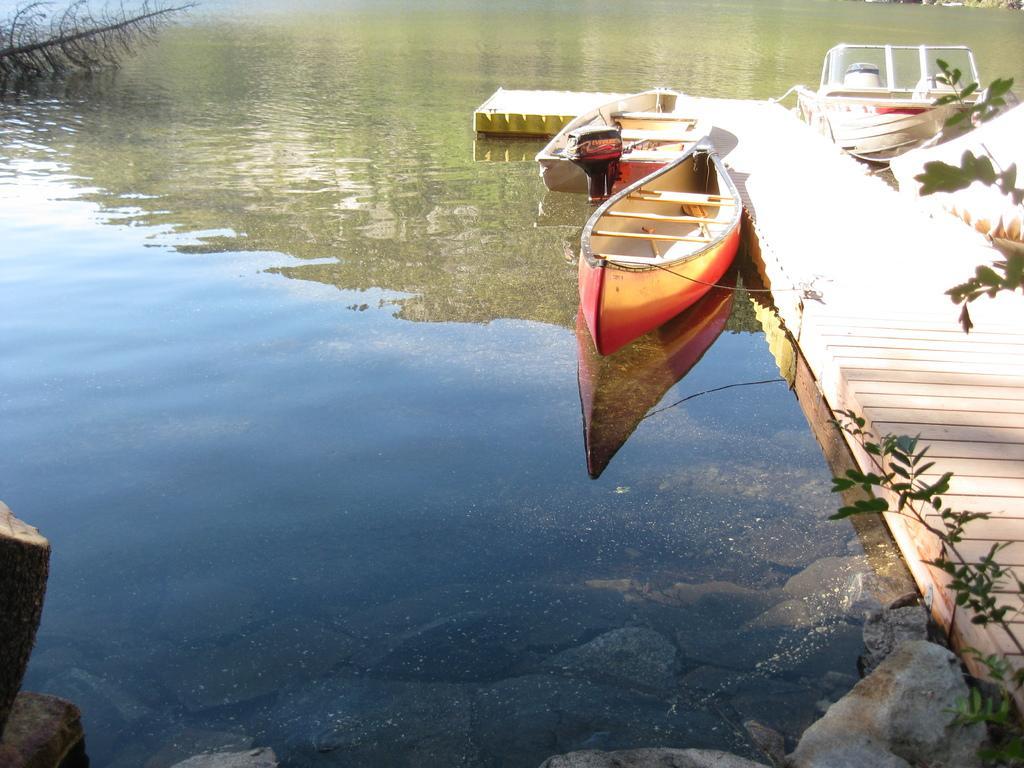Describe this image in one or two sentences. In this picture we can see boats on the river. Here we can see a wooden walking path across the river surrounded by rocks and plants. 